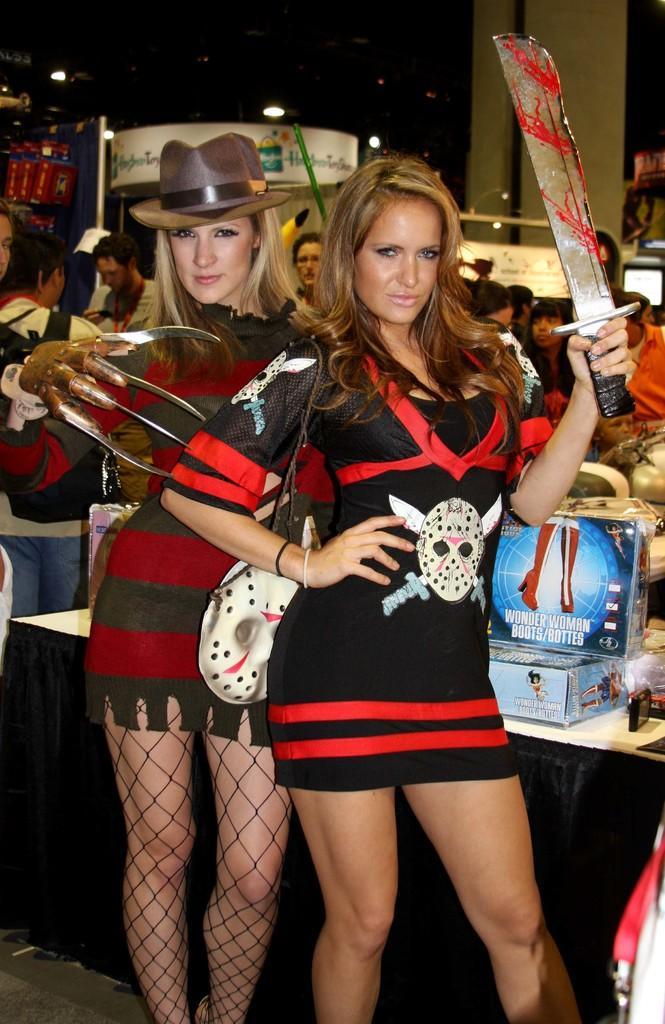Please provide a concise description of this image. In this image we can see two ladies standing and holding swords. In the background there are people and we can see a table. There are cardboard boxes placed on the table and we can see lights. There are boards. 